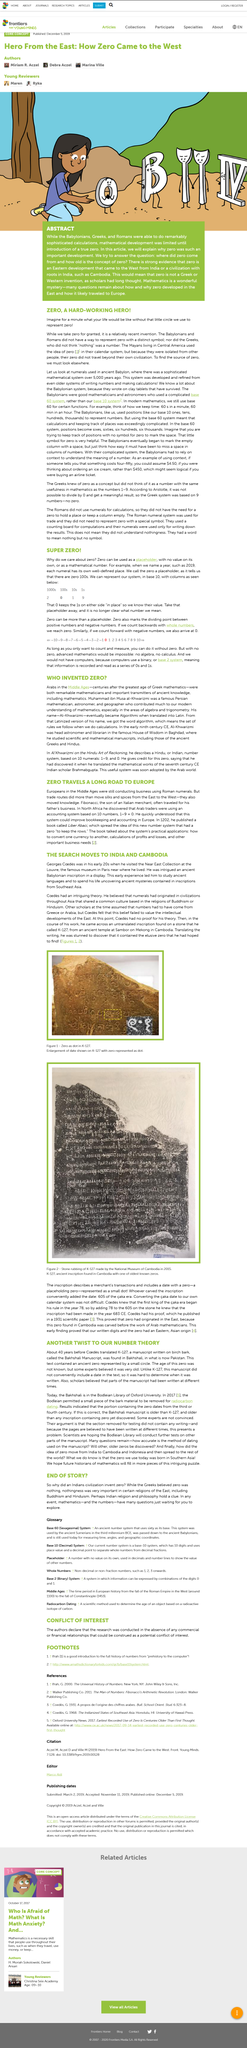Give some essential details in this illustration. The item shown in Figure 1 is from Cambodia. The Mayan civilization in Central America was known for its use of the concept of zero, which was a unique and important contribution to numeral systems. The Babylonians wrote on clay tablets to preserve information. A base 2 system is a method of recording information that utilizes only two possible values, 0s and 1s, to represent it. Babylonians used a base 60 system to represent numbers, which is different from the base 10 system that is commonly used today. 